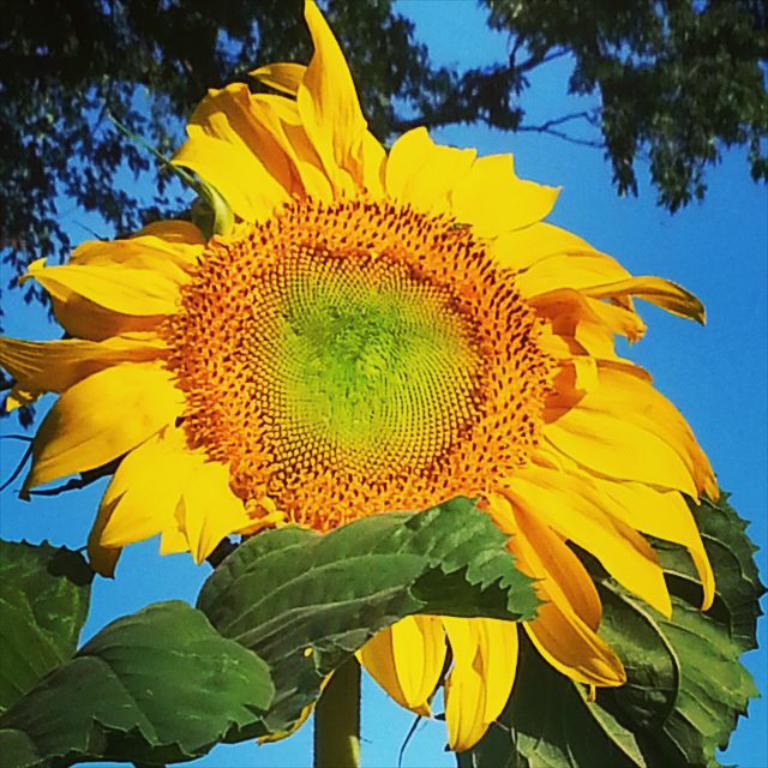What type of vegetation can be seen in the image? There are trees and yellow sunflowers in the image. What else is visible in the image besides the vegetation? The sky is visible in the image. What is the title of the book that is being read in the image? There is no book or reading activity present in the image. 